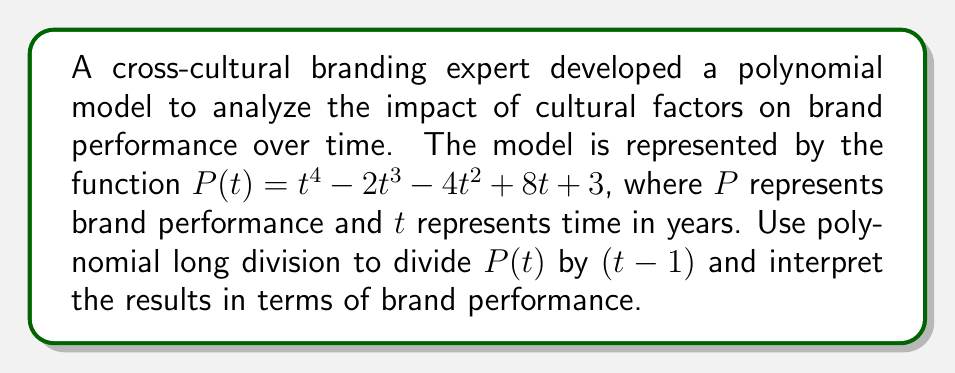Can you answer this question? Let's perform polynomial long division of $P(t)$ by $(t-1)$:

$$\begin{array}{r}
t^3 + t^2 - 3t + 5 \\
t - 1 \enclose{longdiv}{t^4 - 2t^3 - 4t^2 + 8t + 3} \\
\underline{t^4 - t^3} \\
-t^3 - 4t^2 + 8t + 3 \\
\underline{-t^3 + t^2} \\
-3t^2 + 8t + 3 \\
\underline{-3t^2 + 3t} \\
5t + 3 \\
\underline{5t - 5} \\
8
\end{array}$$

The result of the division is:

$P(t) = (t-1)(t^3 + t^2 - 3t + 5) + 8$

Interpreting the results:

1. The quotient $Q(t) = t^3 + t^2 - 3t + 5$ represents the rate of change in brand performance over time, excluding the initial impact.

2. The remainder $R = 8$ indicates the brand's baseline performance when cultural factors are neutralized (i.e., when $t = 1$).

3. The factor $(t-1)$ suggests that the model considers the change in performance relative to the first year $(t = 1)$.

4. The degree of the quotient (3) implies that cultural factors have a complex, non-linear impact on brand performance over time.

5. The positive leading coefficient of the quotient indicates that, in the long term, cultural factors tend to have an increasingly positive impact on brand performance.
Answer: $P(t) = (t-1)(t^3 + t^2 - 3t + 5) + 8$, where $Q(t) = t^3 + t^2 - 3t + 5$ represents the rate of change in brand performance due to cultural factors, and $R = 8$ represents the baseline brand performance. 